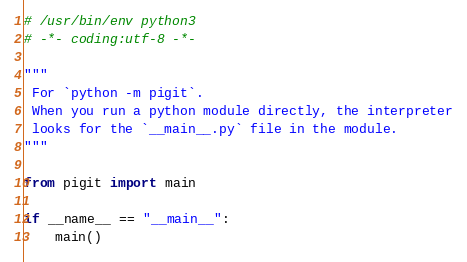<code> <loc_0><loc_0><loc_500><loc_500><_Python_># /usr/bin/env python3
# -*- coding:utf-8 -*-

"""
 For `python -m pigit`.
 When you run a python module directly, the interpreter
 looks for the `__main__.py` file in the module.
"""

from pigit import main

if __name__ == "__main__":
    main()
</code> 